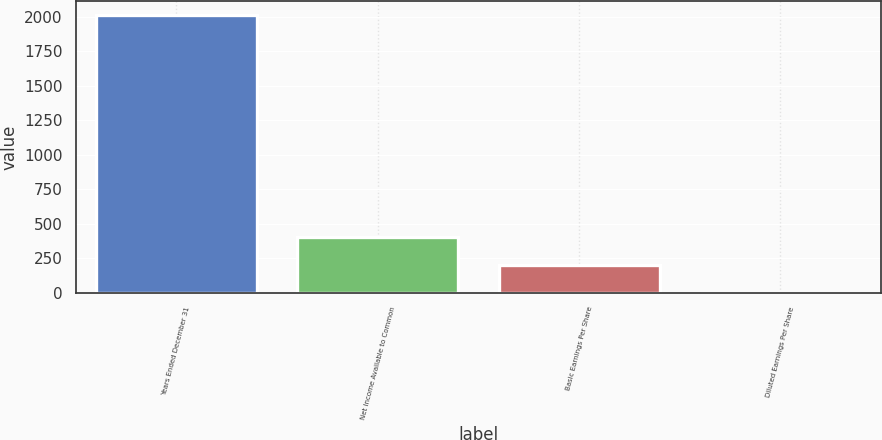<chart> <loc_0><loc_0><loc_500><loc_500><bar_chart><fcel>Years Ended December 31<fcel>Net Income Available to Common<fcel>Basic Earnings Per Share<fcel>Diluted Earnings Per Share<nl><fcel>2010<fcel>403.02<fcel>202.15<fcel>1.28<nl></chart> 